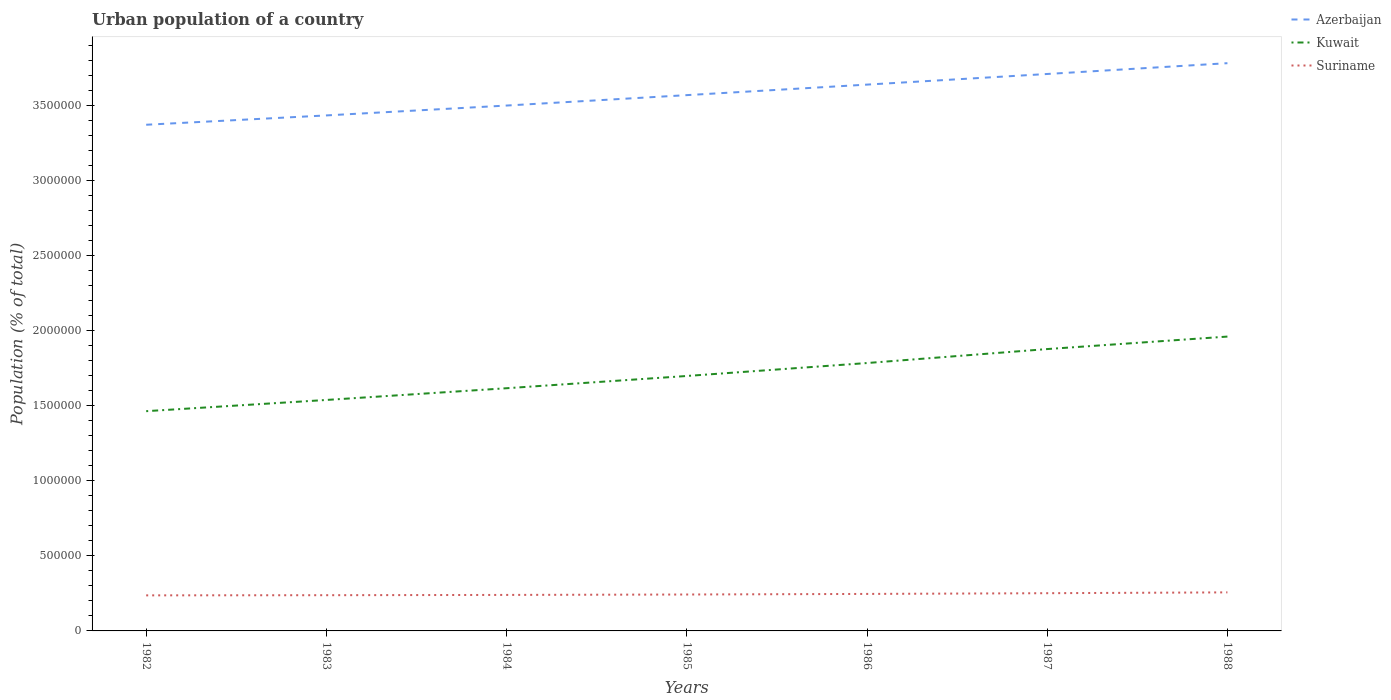How many different coloured lines are there?
Keep it short and to the point. 3. Does the line corresponding to Kuwait intersect with the line corresponding to Azerbaijan?
Your response must be concise. No. Is the number of lines equal to the number of legend labels?
Your answer should be compact. Yes. Across all years, what is the maximum urban population in Kuwait?
Make the answer very short. 1.46e+06. What is the total urban population in Kuwait in the graph?
Your answer should be compact. -1.76e+05. What is the difference between the highest and the second highest urban population in Azerbaijan?
Give a very brief answer. 4.10e+05. How many lines are there?
Keep it short and to the point. 3. How many years are there in the graph?
Offer a very short reply. 7. Does the graph contain grids?
Keep it short and to the point. No. Where does the legend appear in the graph?
Make the answer very short. Top right. What is the title of the graph?
Keep it short and to the point. Urban population of a country. Does "Greece" appear as one of the legend labels in the graph?
Give a very brief answer. No. What is the label or title of the Y-axis?
Your response must be concise. Population (% of total). What is the Population (% of total) in Azerbaijan in 1982?
Offer a terse response. 3.37e+06. What is the Population (% of total) in Kuwait in 1982?
Ensure brevity in your answer.  1.46e+06. What is the Population (% of total) in Suriname in 1982?
Provide a short and direct response. 2.37e+05. What is the Population (% of total) of Azerbaijan in 1983?
Your answer should be very brief. 3.44e+06. What is the Population (% of total) of Kuwait in 1983?
Offer a terse response. 1.54e+06. What is the Population (% of total) in Suriname in 1983?
Give a very brief answer. 2.38e+05. What is the Population (% of total) of Azerbaijan in 1984?
Your answer should be very brief. 3.50e+06. What is the Population (% of total) in Kuwait in 1984?
Offer a very short reply. 1.62e+06. What is the Population (% of total) of Suriname in 1984?
Provide a short and direct response. 2.40e+05. What is the Population (% of total) in Azerbaijan in 1985?
Ensure brevity in your answer.  3.57e+06. What is the Population (% of total) in Kuwait in 1985?
Offer a very short reply. 1.70e+06. What is the Population (% of total) of Suriname in 1985?
Your response must be concise. 2.43e+05. What is the Population (% of total) of Azerbaijan in 1986?
Give a very brief answer. 3.64e+06. What is the Population (% of total) of Kuwait in 1986?
Your answer should be very brief. 1.79e+06. What is the Population (% of total) of Suriname in 1986?
Make the answer very short. 2.47e+05. What is the Population (% of total) in Azerbaijan in 1987?
Your answer should be compact. 3.71e+06. What is the Population (% of total) of Kuwait in 1987?
Keep it short and to the point. 1.88e+06. What is the Population (% of total) of Suriname in 1987?
Provide a succinct answer. 2.51e+05. What is the Population (% of total) in Azerbaijan in 1988?
Offer a terse response. 3.78e+06. What is the Population (% of total) in Kuwait in 1988?
Offer a very short reply. 1.96e+06. What is the Population (% of total) of Suriname in 1988?
Your answer should be compact. 2.57e+05. Across all years, what is the maximum Population (% of total) of Azerbaijan?
Provide a succinct answer. 3.78e+06. Across all years, what is the maximum Population (% of total) in Kuwait?
Provide a succinct answer. 1.96e+06. Across all years, what is the maximum Population (% of total) of Suriname?
Provide a succinct answer. 2.57e+05. Across all years, what is the minimum Population (% of total) of Azerbaijan?
Your answer should be compact. 3.37e+06. Across all years, what is the minimum Population (% of total) in Kuwait?
Your answer should be compact. 1.46e+06. Across all years, what is the minimum Population (% of total) in Suriname?
Provide a succinct answer. 2.37e+05. What is the total Population (% of total) of Azerbaijan in the graph?
Offer a terse response. 2.50e+07. What is the total Population (% of total) in Kuwait in the graph?
Make the answer very short. 1.19e+07. What is the total Population (% of total) of Suriname in the graph?
Offer a terse response. 1.71e+06. What is the difference between the Population (% of total) in Azerbaijan in 1982 and that in 1983?
Offer a terse response. -6.22e+04. What is the difference between the Population (% of total) in Kuwait in 1982 and that in 1983?
Give a very brief answer. -7.48e+04. What is the difference between the Population (% of total) in Suriname in 1982 and that in 1983?
Your answer should be very brief. -1083. What is the difference between the Population (% of total) in Azerbaijan in 1982 and that in 1984?
Offer a very short reply. -1.28e+05. What is the difference between the Population (% of total) in Kuwait in 1982 and that in 1984?
Your answer should be very brief. -1.53e+05. What is the difference between the Population (% of total) in Suriname in 1982 and that in 1984?
Your answer should be very brief. -2903. What is the difference between the Population (% of total) of Azerbaijan in 1982 and that in 1985?
Make the answer very short. -1.97e+05. What is the difference between the Population (% of total) in Kuwait in 1982 and that in 1985?
Ensure brevity in your answer.  -2.35e+05. What is the difference between the Population (% of total) in Suriname in 1982 and that in 1985?
Provide a succinct answer. -5700. What is the difference between the Population (% of total) of Azerbaijan in 1982 and that in 1986?
Offer a very short reply. -2.67e+05. What is the difference between the Population (% of total) of Kuwait in 1982 and that in 1986?
Your answer should be compact. -3.21e+05. What is the difference between the Population (% of total) in Suriname in 1982 and that in 1986?
Your response must be concise. -9574. What is the difference between the Population (% of total) of Azerbaijan in 1982 and that in 1987?
Offer a very short reply. -3.38e+05. What is the difference between the Population (% of total) of Kuwait in 1982 and that in 1987?
Provide a short and direct response. -4.14e+05. What is the difference between the Population (% of total) in Suriname in 1982 and that in 1987?
Provide a succinct answer. -1.44e+04. What is the difference between the Population (% of total) in Azerbaijan in 1982 and that in 1988?
Give a very brief answer. -4.10e+05. What is the difference between the Population (% of total) of Kuwait in 1982 and that in 1988?
Ensure brevity in your answer.  -4.97e+05. What is the difference between the Population (% of total) of Suriname in 1982 and that in 1988?
Keep it short and to the point. -1.99e+04. What is the difference between the Population (% of total) of Azerbaijan in 1983 and that in 1984?
Ensure brevity in your answer.  -6.58e+04. What is the difference between the Population (% of total) of Kuwait in 1983 and that in 1984?
Provide a succinct answer. -7.82e+04. What is the difference between the Population (% of total) in Suriname in 1983 and that in 1984?
Make the answer very short. -1820. What is the difference between the Population (% of total) in Azerbaijan in 1983 and that in 1985?
Your response must be concise. -1.35e+05. What is the difference between the Population (% of total) in Kuwait in 1983 and that in 1985?
Your answer should be very brief. -1.60e+05. What is the difference between the Population (% of total) of Suriname in 1983 and that in 1985?
Offer a very short reply. -4617. What is the difference between the Population (% of total) of Azerbaijan in 1983 and that in 1986?
Offer a terse response. -2.05e+05. What is the difference between the Population (% of total) in Kuwait in 1983 and that in 1986?
Provide a succinct answer. -2.46e+05. What is the difference between the Population (% of total) in Suriname in 1983 and that in 1986?
Your response must be concise. -8491. What is the difference between the Population (% of total) of Azerbaijan in 1983 and that in 1987?
Ensure brevity in your answer.  -2.76e+05. What is the difference between the Population (% of total) of Kuwait in 1983 and that in 1987?
Offer a terse response. -3.39e+05. What is the difference between the Population (% of total) of Suriname in 1983 and that in 1987?
Provide a short and direct response. -1.33e+04. What is the difference between the Population (% of total) of Azerbaijan in 1983 and that in 1988?
Provide a succinct answer. -3.48e+05. What is the difference between the Population (% of total) of Kuwait in 1983 and that in 1988?
Give a very brief answer. -4.22e+05. What is the difference between the Population (% of total) in Suriname in 1983 and that in 1988?
Your answer should be very brief. -1.88e+04. What is the difference between the Population (% of total) of Azerbaijan in 1984 and that in 1985?
Offer a terse response. -6.94e+04. What is the difference between the Population (% of total) in Kuwait in 1984 and that in 1985?
Ensure brevity in your answer.  -8.16e+04. What is the difference between the Population (% of total) in Suriname in 1984 and that in 1985?
Ensure brevity in your answer.  -2797. What is the difference between the Population (% of total) in Azerbaijan in 1984 and that in 1986?
Your response must be concise. -1.40e+05. What is the difference between the Population (% of total) of Kuwait in 1984 and that in 1986?
Make the answer very short. -1.68e+05. What is the difference between the Population (% of total) in Suriname in 1984 and that in 1986?
Your answer should be very brief. -6671. What is the difference between the Population (% of total) in Azerbaijan in 1984 and that in 1987?
Your response must be concise. -2.10e+05. What is the difference between the Population (% of total) in Kuwait in 1984 and that in 1987?
Offer a very short reply. -2.61e+05. What is the difference between the Population (% of total) of Suriname in 1984 and that in 1987?
Your answer should be compact. -1.15e+04. What is the difference between the Population (% of total) of Azerbaijan in 1984 and that in 1988?
Offer a terse response. -2.82e+05. What is the difference between the Population (% of total) in Kuwait in 1984 and that in 1988?
Give a very brief answer. -3.44e+05. What is the difference between the Population (% of total) of Suriname in 1984 and that in 1988?
Keep it short and to the point. -1.70e+04. What is the difference between the Population (% of total) of Azerbaijan in 1985 and that in 1986?
Your answer should be very brief. -7.01e+04. What is the difference between the Population (% of total) in Kuwait in 1985 and that in 1986?
Provide a short and direct response. -8.63e+04. What is the difference between the Population (% of total) in Suriname in 1985 and that in 1986?
Your answer should be very brief. -3874. What is the difference between the Population (% of total) in Azerbaijan in 1985 and that in 1987?
Your answer should be compact. -1.41e+05. What is the difference between the Population (% of total) in Kuwait in 1985 and that in 1987?
Provide a succinct answer. -1.79e+05. What is the difference between the Population (% of total) of Suriname in 1985 and that in 1987?
Keep it short and to the point. -8704. What is the difference between the Population (% of total) of Azerbaijan in 1985 and that in 1988?
Your answer should be compact. -2.13e+05. What is the difference between the Population (% of total) of Kuwait in 1985 and that in 1988?
Offer a terse response. -2.63e+05. What is the difference between the Population (% of total) in Suriname in 1985 and that in 1988?
Offer a very short reply. -1.42e+04. What is the difference between the Population (% of total) in Azerbaijan in 1986 and that in 1987?
Your response must be concise. -7.08e+04. What is the difference between the Population (% of total) of Kuwait in 1986 and that in 1987?
Your response must be concise. -9.31e+04. What is the difference between the Population (% of total) in Suriname in 1986 and that in 1987?
Provide a short and direct response. -4830. What is the difference between the Population (% of total) in Azerbaijan in 1986 and that in 1988?
Keep it short and to the point. -1.43e+05. What is the difference between the Population (% of total) of Kuwait in 1986 and that in 1988?
Provide a short and direct response. -1.76e+05. What is the difference between the Population (% of total) in Suriname in 1986 and that in 1988?
Your answer should be compact. -1.03e+04. What is the difference between the Population (% of total) in Azerbaijan in 1987 and that in 1988?
Give a very brief answer. -7.20e+04. What is the difference between the Population (% of total) in Kuwait in 1987 and that in 1988?
Make the answer very short. -8.32e+04. What is the difference between the Population (% of total) of Suriname in 1987 and that in 1988?
Your answer should be compact. -5486. What is the difference between the Population (% of total) of Azerbaijan in 1982 and the Population (% of total) of Kuwait in 1983?
Your answer should be very brief. 1.83e+06. What is the difference between the Population (% of total) of Azerbaijan in 1982 and the Population (% of total) of Suriname in 1983?
Ensure brevity in your answer.  3.14e+06. What is the difference between the Population (% of total) of Kuwait in 1982 and the Population (% of total) of Suriname in 1983?
Offer a terse response. 1.23e+06. What is the difference between the Population (% of total) of Azerbaijan in 1982 and the Population (% of total) of Kuwait in 1984?
Your answer should be very brief. 1.76e+06. What is the difference between the Population (% of total) of Azerbaijan in 1982 and the Population (% of total) of Suriname in 1984?
Provide a short and direct response. 3.13e+06. What is the difference between the Population (% of total) of Kuwait in 1982 and the Population (% of total) of Suriname in 1984?
Your answer should be very brief. 1.22e+06. What is the difference between the Population (% of total) of Azerbaijan in 1982 and the Population (% of total) of Kuwait in 1985?
Offer a terse response. 1.67e+06. What is the difference between the Population (% of total) of Azerbaijan in 1982 and the Population (% of total) of Suriname in 1985?
Provide a succinct answer. 3.13e+06. What is the difference between the Population (% of total) of Kuwait in 1982 and the Population (% of total) of Suriname in 1985?
Provide a succinct answer. 1.22e+06. What is the difference between the Population (% of total) in Azerbaijan in 1982 and the Population (% of total) in Kuwait in 1986?
Make the answer very short. 1.59e+06. What is the difference between the Population (% of total) of Azerbaijan in 1982 and the Population (% of total) of Suriname in 1986?
Make the answer very short. 3.13e+06. What is the difference between the Population (% of total) of Kuwait in 1982 and the Population (% of total) of Suriname in 1986?
Give a very brief answer. 1.22e+06. What is the difference between the Population (% of total) in Azerbaijan in 1982 and the Population (% of total) in Kuwait in 1987?
Provide a succinct answer. 1.49e+06. What is the difference between the Population (% of total) in Azerbaijan in 1982 and the Population (% of total) in Suriname in 1987?
Give a very brief answer. 3.12e+06. What is the difference between the Population (% of total) in Kuwait in 1982 and the Population (% of total) in Suriname in 1987?
Ensure brevity in your answer.  1.21e+06. What is the difference between the Population (% of total) of Azerbaijan in 1982 and the Population (% of total) of Kuwait in 1988?
Your answer should be compact. 1.41e+06. What is the difference between the Population (% of total) in Azerbaijan in 1982 and the Population (% of total) in Suriname in 1988?
Offer a terse response. 3.12e+06. What is the difference between the Population (% of total) in Kuwait in 1982 and the Population (% of total) in Suriname in 1988?
Your answer should be very brief. 1.21e+06. What is the difference between the Population (% of total) of Azerbaijan in 1983 and the Population (% of total) of Kuwait in 1984?
Offer a terse response. 1.82e+06. What is the difference between the Population (% of total) of Azerbaijan in 1983 and the Population (% of total) of Suriname in 1984?
Give a very brief answer. 3.20e+06. What is the difference between the Population (% of total) of Kuwait in 1983 and the Population (% of total) of Suriname in 1984?
Make the answer very short. 1.30e+06. What is the difference between the Population (% of total) of Azerbaijan in 1983 and the Population (% of total) of Kuwait in 1985?
Offer a terse response. 1.74e+06. What is the difference between the Population (% of total) of Azerbaijan in 1983 and the Population (% of total) of Suriname in 1985?
Keep it short and to the point. 3.19e+06. What is the difference between the Population (% of total) in Kuwait in 1983 and the Population (% of total) in Suriname in 1985?
Provide a short and direct response. 1.30e+06. What is the difference between the Population (% of total) in Azerbaijan in 1983 and the Population (% of total) in Kuwait in 1986?
Provide a short and direct response. 1.65e+06. What is the difference between the Population (% of total) in Azerbaijan in 1983 and the Population (% of total) in Suriname in 1986?
Your answer should be very brief. 3.19e+06. What is the difference between the Population (% of total) of Kuwait in 1983 and the Population (% of total) of Suriname in 1986?
Keep it short and to the point. 1.29e+06. What is the difference between the Population (% of total) of Azerbaijan in 1983 and the Population (% of total) of Kuwait in 1987?
Make the answer very short. 1.56e+06. What is the difference between the Population (% of total) in Azerbaijan in 1983 and the Population (% of total) in Suriname in 1987?
Offer a very short reply. 3.18e+06. What is the difference between the Population (% of total) in Kuwait in 1983 and the Population (% of total) in Suriname in 1987?
Offer a very short reply. 1.29e+06. What is the difference between the Population (% of total) of Azerbaijan in 1983 and the Population (% of total) of Kuwait in 1988?
Offer a very short reply. 1.47e+06. What is the difference between the Population (% of total) of Azerbaijan in 1983 and the Population (% of total) of Suriname in 1988?
Offer a very short reply. 3.18e+06. What is the difference between the Population (% of total) of Kuwait in 1983 and the Population (% of total) of Suriname in 1988?
Your answer should be very brief. 1.28e+06. What is the difference between the Population (% of total) in Azerbaijan in 1984 and the Population (% of total) in Kuwait in 1985?
Give a very brief answer. 1.80e+06. What is the difference between the Population (% of total) in Azerbaijan in 1984 and the Population (% of total) in Suriname in 1985?
Ensure brevity in your answer.  3.26e+06. What is the difference between the Population (% of total) in Kuwait in 1984 and the Population (% of total) in Suriname in 1985?
Your response must be concise. 1.37e+06. What is the difference between the Population (% of total) of Azerbaijan in 1984 and the Population (% of total) of Kuwait in 1986?
Your answer should be compact. 1.72e+06. What is the difference between the Population (% of total) in Azerbaijan in 1984 and the Population (% of total) in Suriname in 1986?
Give a very brief answer. 3.25e+06. What is the difference between the Population (% of total) of Kuwait in 1984 and the Population (% of total) of Suriname in 1986?
Your answer should be compact. 1.37e+06. What is the difference between the Population (% of total) of Azerbaijan in 1984 and the Population (% of total) of Kuwait in 1987?
Your answer should be very brief. 1.62e+06. What is the difference between the Population (% of total) in Azerbaijan in 1984 and the Population (% of total) in Suriname in 1987?
Provide a succinct answer. 3.25e+06. What is the difference between the Population (% of total) of Kuwait in 1984 and the Population (% of total) of Suriname in 1987?
Your answer should be very brief. 1.37e+06. What is the difference between the Population (% of total) in Azerbaijan in 1984 and the Population (% of total) in Kuwait in 1988?
Give a very brief answer. 1.54e+06. What is the difference between the Population (% of total) in Azerbaijan in 1984 and the Population (% of total) in Suriname in 1988?
Your answer should be compact. 3.24e+06. What is the difference between the Population (% of total) of Kuwait in 1984 and the Population (% of total) of Suriname in 1988?
Give a very brief answer. 1.36e+06. What is the difference between the Population (% of total) of Azerbaijan in 1985 and the Population (% of total) of Kuwait in 1986?
Keep it short and to the point. 1.79e+06. What is the difference between the Population (% of total) of Azerbaijan in 1985 and the Population (% of total) of Suriname in 1986?
Your answer should be compact. 3.32e+06. What is the difference between the Population (% of total) of Kuwait in 1985 and the Population (% of total) of Suriname in 1986?
Ensure brevity in your answer.  1.45e+06. What is the difference between the Population (% of total) of Azerbaijan in 1985 and the Population (% of total) of Kuwait in 1987?
Provide a short and direct response. 1.69e+06. What is the difference between the Population (% of total) in Azerbaijan in 1985 and the Population (% of total) in Suriname in 1987?
Keep it short and to the point. 3.32e+06. What is the difference between the Population (% of total) of Kuwait in 1985 and the Population (% of total) of Suriname in 1987?
Provide a short and direct response. 1.45e+06. What is the difference between the Population (% of total) of Azerbaijan in 1985 and the Population (% of total) of Kuwait in 1988?
Your answer should be very brief. 1.61e+06. What is the difference between the Population (% of total) in Azerbaijan in 1985 and the Population (% of total) in Suriname in 1988?
Offer a terse response. 3.31e+06. What is the difference between the Population (% of total) in Kuwait in 1985 and the Population (% of total) in Suriname in 1988?
Provide a succinct answer. 1.44e+06. What is the difference between the Population (% of total) in Azerbaijan in 1986 and the Population (% of total) in Kuwait in 1987?
Provide a succinct answer. 1.76e+06. What is the difference between the Population (% of total) of Azerbaijan in 1986 and the Population (% of total) of Suriname in 1987?
Make the answer very short. 3.39e+06. What is the difference between the Population (% of total) in Kuwait in 1986 and the Population (% of total) in Suriname in 1987?
Offer a terse response. 1.53e+06. What is the difference between the Population (% of total) in Azerbaijan in 1986 and the Population (% of total) in Kuwait in 1988?
Provide a short and direct response. 1.68e+06. What is the difference between the Population (% of total) of Azerbaijan in 1986 and the Population (% of total) of Suriname in 1988?
Offer a very short reply. 3.38e+06. What is the difference between the Population (% of total) in Kuwait in 1986 and the Population (% of total) in Suriname in 1988?
Your answer should be compact. 1.53e+06. What is the difference between the Population (% of total) in Azerbaijan in 1987 and the Population (% of total) in Kuwait in 1988?
Your answer should be compact. 1.75e+06. What is the difference between the Population (% of total) of Azerbaijan in 1987 and the Population (% of total) of Suriname in 1988?
Your response must be concise. 3.45e+06. What is the difference between the Population (% of total) in Kuwait in 1987 and the Population (% of total) in Suriname in 1988?
Give a very brief answer. 1.62e+06. What is the average Population (% of total) in Azerbaijan per year?
Provide a succinct answer. 3.57e+06. What is the average Population (% of total) of Kuwait per year?
Give a very brief answer. 1.71e+06. What is the average Population (% of total) in Suriname per year?
Offer a very short reply. 2.45e+05. In the year 1982, what is the difference between the Population (% of total) in Azerbaijan and Population (% of total) in Kuwait?
Give a very brief answer. 1.91e+06. In the year 1982, what is the difference between the Population (% of total) in Azerbaijan and Population (% of total) in Suriname?
Your response must be concise. 3.14e+06. In the year 1982, what is the difference between the Population (% of total) of Kuwait and Population (% of total) of Suriname?
Offer a terse response. 1.23e+06. In the year 1983, what is the difference between the Population (% of total) in Azerbaijan and Population (% of total) in Kuwait?
Ensure brevity in your answer.  1.90e+06. In the year 1983, what is the difference between the Population (% of total) of Azerbaijan and Population (% of total) of Suriname?
Keep it short and to the point. 3.20e+06. In the year 1983, what is the difference between the Population (% of total) of Kuwait and Population (% of total) of Suriname?
Make the answer very short. 1.30e+06. In the year 1984, what is the difference between the Population (% of total) in Azerbaijan and Population (% of total) in Kuwait?
Provide a short and direct response. 1.88e+06. In the year 1984, what is the difference between the Population (% of total) in Azerbaijan and Population (% of total) in Suriname?
Your answer should be very brief. 3.26e+06. In the year 1984, what is the difference between the Population (% of total) of Kuwait and Population (% of total) of Suriname?
Ensure brevity in your answer.  1.38e+06. In the year 1985, what is the difference between the Population (% of total) of Azerbaijan and Population (% of total) of Kuwait?
Offer a terse response. 1.87e+06. In the year 1985, what is the difference between the Population (% of total) in Azerbaijan and Population (% of total) in Suriname?
Provide a succinct answer. 3.33e+06. In the year 1985, what is the difference between the Population (% of total) in Kuwait and Population (% of total) in Suriname?
Your response must be concise. 1.46e+06. In the year 1986, what is the difference between the Population (% of total) of Azerbaijan and Population (% of total) of Kuwait?
Provide a succinct answer. 1.86e+06. In the year 1986, what is the difference between the Population (% of total) in Azerbaijan and Population (% of total) in Suriname?
Your answer should be very brief. 3.39e+06. In the year 1986, what is the difference between the Population (% of total) in Kuwait and Population (% of total) in Suriname?
Provide a succinct answer. 1.54e+06. In the year 1987, what is the difference between the Population (% of total) of Azerbaijan and Population (% of total) of Kuwait?
Provide a succinct answer. 1.83e+06. In the year 1987, what is the difference between the Population (% of total) of Azerbaijan and Population (% of total) of Suriname?
Your answer should be compact. 3.46e+06. In the year 1987, what is the difference between the Population (% of total) in Kuwait and Population (% of total) in Suriname?
Your response must be concise. 1.63e+06. In the year 1988, what is the difference between the Population (% of total) in Azerbaijan and Population (% of total) in Kuwait?
Offer a terse response. 1.82e+06. In the year 1988, what is the difference between the Population (% of total) in Azerbaijan and Population (% of total) in Suriname?
Provide a short and direct response. 3.53e+06. In the year 1988, what is the difference between the Population (% of total) in Kuwait and Population (% of total) in Suriname?
Keep it short and to the point. 1.70e+06. What is the ratio of the Population (% of total) of Azerbaijan in 1982 to that in 1983?
Give a very brief answer. 0.98. What is the ratio of the Population (% of total) of Kuwait in 1982 to that in 1983?
Offer a terse response. 0.95. What is the ratio of the Population (% of total) of Suriname in 1982 to that in 1983?
Offer a very short reply. 1. What is the ratio of the Population (% of total) in Azerbaijan in 1982 to that in 1984?
Keep it short and to the point. 0.96. What is the ratio of the Population (% of total) in Kuwait in 1982 to that in 1984?
Provide a succinct answer. 0.91. What is the ratio of the Population (% of total) of Suriname in 1982 to that in 1984?
Make the answer very short. 0.99. What is the ratio of the Population (% of total) in Azerbaijan in 1982 to that in 1985?
Keep it short and to the point. 0.94. What is the ratio of the Population (% of total) in Kuwait in 1982 to that in 1985?
Offer a terse response. 0.86. What is the ratio of the Population (% of total) in Suriname in 1982 to that in 1985?
Make the answer very short. 0.98. What is the ratio of the Population (% of total) of Azerbaijan in 1982 to that in 1986?
Ensure brevity in your answer.  0.93. What is the ratio of the Population (% of total) of Kuwait in 1982 to that in 1986?
Offer a terse response. 0.82. What is the ratio of the Population (% of total) of Suriname in 1982 to that in 1986?
Provide a succinct answer. 0.96. What is the ratio of the Population (% of total) of Azerbaijan in 1982 to that in 1987?
Offer a terse response. 0.91. What is the ratio of the Population (% of total) of Kuwait in 1982 to that in 1987?
Your answer should be compact. 0.78. What is the ratio of the Population (% of total) in Suriname in 1982 to that in 1987?
Provide a short and direct response. 0.94. What is the ratio of the Population (% of total) in Azerbaijan in 1982 to that in 1988?
Your answer should be compact. 0.89. What is the ratio of the Population (% of total) of Kuwait in 1982 to that in 1988?
Make the answer very short. 0.75. What is the ratio of the Population (% of total) of Suriname in 1982 to that in 1988?
Your answer should be compact. 0.92. What is the ratio of the Population (% of total) of Azerbaijan in 1983 to that in 1984?
Ensure brevity in your answer.  0.98. What is the ratio of the Population (% of total) of Kuwait in 1983 to that in 1984?
Offer a terse response. 0.95. What is the ratio of the Population (% of total) of Azerbaijan in 1983 to that in 1985?
Your answer should be compact. 0.96. What is the ratio of the Population (% of total) in Kuwait in 1983 to that in 1985?
Give a very brief answer. 0.91. What is the ratio of the Population (% of total) of Azerbaijan in 1983 to that in 1986?
Your answer should be compact. 0.94. What is the ratio of the Population (% of total) in Kuwait in 1983 to that in 1986?
Provide a short and direct response. 0.86. What is the ratio of the Population (% of total) in Suriname in 1983 to that in 1986?
Make the answer very short. 0.97. What is the ratio of the Population (% of total) of Azerbaijan in 1983 to that in 1987?
Ensure brevity in your answer.  0.93. What is the ratio of the Population (% of total) of Kuwait in 1983 to that in 1987?
Offer a terse response. 0.82. What is the ratio of the Population (% of total) in Suriname in 1983 to that in 1987?
Your answer should be compact. 0.95. What is the ratio of the Population (% of total) of Azerbaijan in 1983 to that in 1988?
Provide a short and direct response. 0.91. What is the ratio of the Population (% of total) in Kuwait in 1983 to that in 1988?
Your response must be concise. 0.78. What is the ratio of the Population (% of total) in Suriname in 1983 to that in 1988?
Offer a terse response. 0.93. What is the ratio of the Population (% of total) of Azerbaijan in 1984 to that in 1985?
Your answer should be very brief. 0.98. What is the ratio of the Population (% of total) in Kuwait in 1984 to that in 1985?
Your response must be concise. 0.95. What is the ratio of the Population (% of total) of Azerbaijan in 1984 to that in 1986?
Offer a terse response. 0.96. What is the ratio of the Population (% of total) in Kuwait in 1984 to that in 1986?
Offer a very short reply. 0.91. What is the ratio of the Population (% of total) of Suriname in 1984 to that in 1986?
Provide a succinct answer. 0.97. What is the ratio of the Population (% of total) in Azerbaijan in 1984 to that in 1987?
Your response must be concise. 0.94. What is the ratio of the Population (% of total) in Kuwait in 1984 to that in 1987?
Your response must be concise. 0.86. What is the ratio of the Population (% of total) of Suriname in 1984 to that in 1987?
Make the answer very short. 0.95. What is the ratio of the Population (% of total) in Azerbaijan in 1984 to that in 1988?
Your response must be concise. 0.93. What is the ratio of the Population (% of total) of Kuwait in 1984 to that in 1988?
Provide a short and direct response. 0.82. What is the ratio of the Population (% of total) in Suriname in 1984 to that in 1988?
Keep it short and to the point. 0.93. What is the ratio of the Population (% of total) in Azerbaijan in 1985 to that in 1986?
Provide a short and direct response. 0.98. What is the ratio of the Population (% of total) of Kuwait in 1985 to that in 1986?
Offer a very short reply. 0.95. What is the ratio of the Population (% of total) in Suriname in 1985 to that in 1986?
Your response must be concise. 0.98. What is the ratio of the Population (% of total) in Azerbaijan in 1985 to that in 1987?
Your answer should be very brief. 0.96. What is the ratio of the Population (% of total) of Kuwait in 1985 to that in 1987?
Provide a succinct answer. 0.9. What is the ratio of the Population (% of total) of Suriname in 1985 to that in 1987?
Your answer should be compact. 0.97. What is the ratio of the Population (% of total) of Azerbaijan in 1985 to that in 1988?
Offer a terse response. 0.94. What is the ratio of the Population (% of total) of Kuwait in 1985 to that in 1988?
Provide a short and direct response. 0.87. What is the ratio of the Population (% of total) of Suriname in 1985 to that in 1988?
Make the answer very short. 0.94. What is the ratio of the Population (% of total) in Azerbaijan in 1986 to that in 1987?
Provide a succinct answer. 0.98. What is the ratio of the Population (% of total) in Kuwait in 1986 to that in 1987?
Offer a very short reply. 0.95. What is the ratio of the Population (% of total) of Suriname in 1986 to that in 1987?
Provide a succinct answer. 0.98. What is the ratio of the Population (% of total) of Azerbaijan in 1986 to that in 1988?
Offer a very short reply. 0.96. What is the ratio of the Population (% of total) in Kuwait in 1986 to that in 1988?
Offer a very short reply. 0.91. What is the ratio of the Population (% of total) of Suriname in 1986 to that in 1988?
Give a very brief answer. 0.96. What is the ratio of the Population (% of total) of Kuwait in 1987 to that in 1988?
Give a very brief answer. 0.96. What is the ratio of the Population (% of total) in Suriname in 1987 to that in 1988?
Your answer should be very brief. 0.98. What is the difference between the highest and the second highest Population (% of total) in Azerbaijan?
Give a very brief answer. 7.20e+04. What is the difference between the highest and the second highest Population (% of total) in Kuwait?
Your answer should be very brief. 8.32e+04. What is the difference between the highest and the second highest Population (% of total) in Suriname?
Offer a terse response. 5486. What is the difference between the highest and the lowest Population (% of total) in Azerbaijan?
Your answer should be very brief. 4.10e+05. What is the difference between the highest and the lowest Population (% of total) of Kuwait?
Your answer should be compact. 4.97e+05. What is the difference between the highest and the lowest Population (% of total) of Suriname?
Keep it short and to the point. 1.99e+04. 